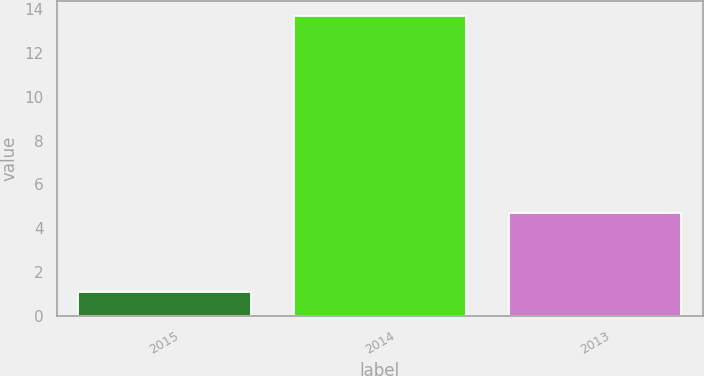Convert chart to OTSL. <chart><loc_0><loc_0><loc_500><loc_500><bar_chart><fcel>2015<fcel>2014<fcel>2013<nl><fcel>1.1<fcel>13.7<fcel>4.7<nl></chart> 